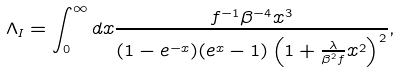Convert formula to latex. <formula><loc_0><loc_0><loc_500><loc_500>\Lambda _ { I } = \int ^ { \infty } _ { 0 } d x \frac { f ^ { - 1 } \beta ^ { - 4 } x ^ { 3 } } { ( 1 - e ^ { - x } ) ( e ^ { x } - 1 ) \left ( 1 + \frac { \lambda } { \beta ^ { 2 } f } x ^ { 2 } \right ) ^ { 2 } } , \\</formula> 